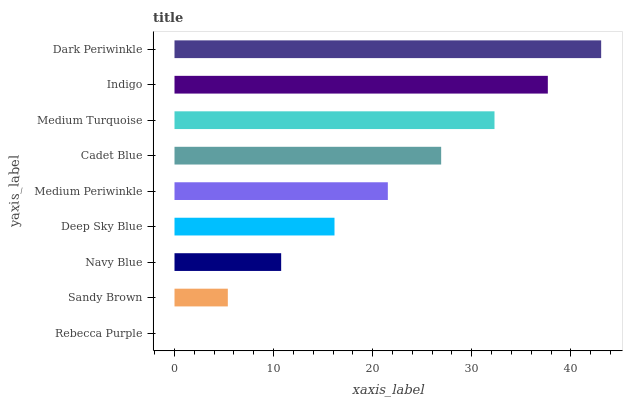Is Rebecca Purple the minimum?
Answer yes or no. Yes. Is Dark Periwinkle the maximum?
Answer yes or no. Yes. Is Sandy Brown the minimum?
Answer yes or no. No. Is Sandy Brown the maximum?
Answer yes or no. No. Is Sandy Brown greater than Rebecca Purple?
Answer yes or no. Yes. Is Rebecca Purple less than Sandy Brown?
Answer yes or no. Yes. Is Rebecca Purple greater than Sandy Brown?
Answer yes or no. No. Is Sandy Brown less than Rebecca Purple?
Answer yes or no. No. Is Medium Periwinkle the high median?
Answer yes or no. Yes. Is Medium Periwinkle the low median?
Answer yes or no. Yes. Is Deep Sky Blue the high median?
Answer yes or no. No. Is Medium Turquoise the low median?
Answer yes or no. No. 